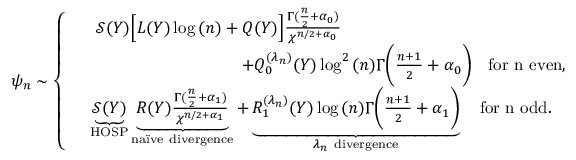<formula> <loc_0><loc_0><loc_500><loc_500>\psi _ { n } \sim \left \{ \begin{array} { r l } & { \mathcal { S } ( Y ) \left [ L ( Y ) \log { ( n ) } + Q ( Y ) \right ] \frac { \Gamma ( \frac { n } { 2 } + \alpha _ { 0 } ) } { \chi ^ { n / 2 + \alpha _ { 0 } } } \quad } \\ & { \quad + Q _ { 0 } ^ { ( \lambda _ { n } ) } ( Y ) \log ^ { 2 } { ( n ) } \Gamma \left ( \frac { n + 1 } { 2 } + \alpha _ { 0 } \right ) \quad f o r n e v e n , } \\ & { \underbrace { \mathcal { S } ( Y ) } _ { H O S P } \underbrace { R ( Y ) \frac { \Gamma ( \frac { n } { 2 } + \alpha _ { 1 } ) } { \chi ^ { n / 2 + \alpha _ { 1 } } } } _ { n a \ " i v e d i v e r g e n c e } + \underbrace { R _ { 1 } ^ { ( \lambda _ { n } ) } ( Y ) \log { ( n ) } \Gamma \left ( \frac { n + 1 } { 2 } + \alpha _ { 1 } \right ) } _ { { \lambda _ { n } d i v e r g e n c e } } \quad f o r n o d d . } \end{array}</formula> 